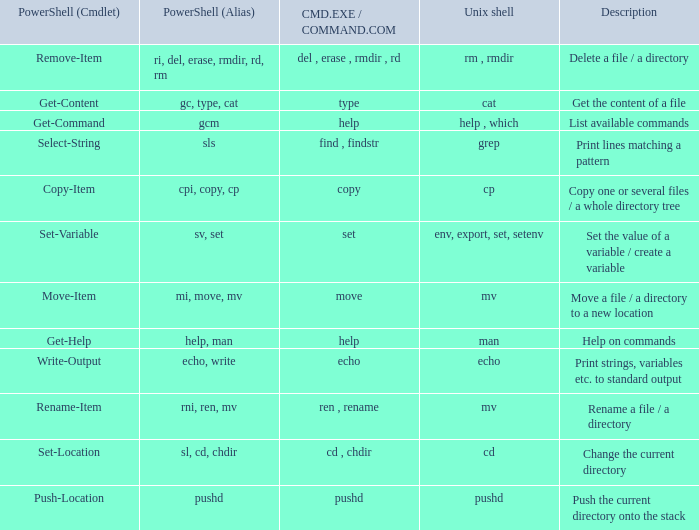If Powershell (alias) is cpi, copy, cp, what are all corresponding descriptions.  Copy one or several files / a whole directory tree. 